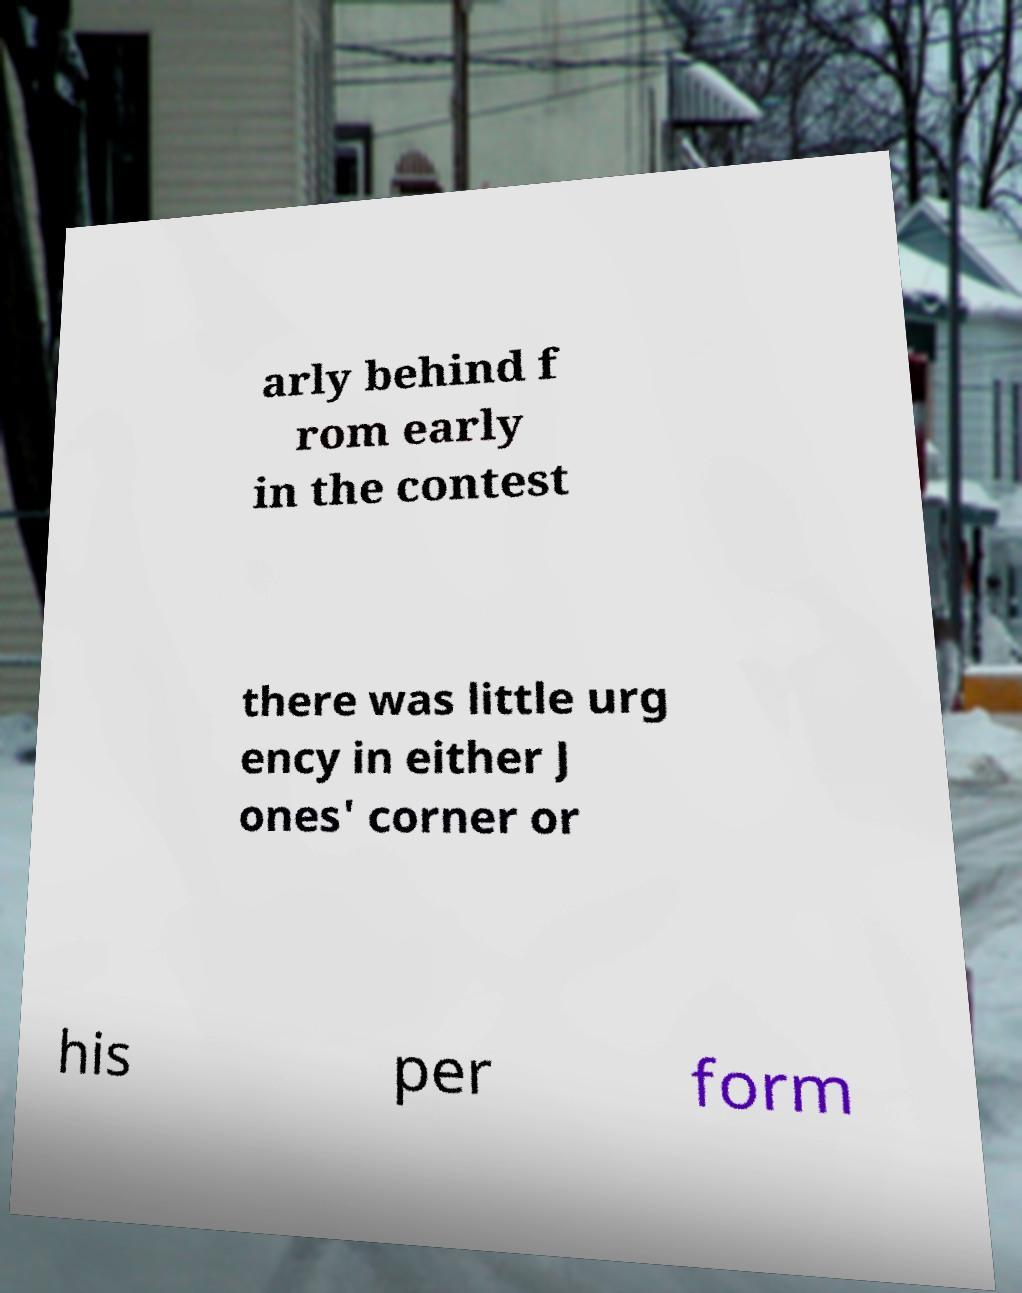Could you assist in decoding the text presented in this image and type it out clearly? arly behind f rom early in the contest there was little urg ency in either J ones' corner or his per form 